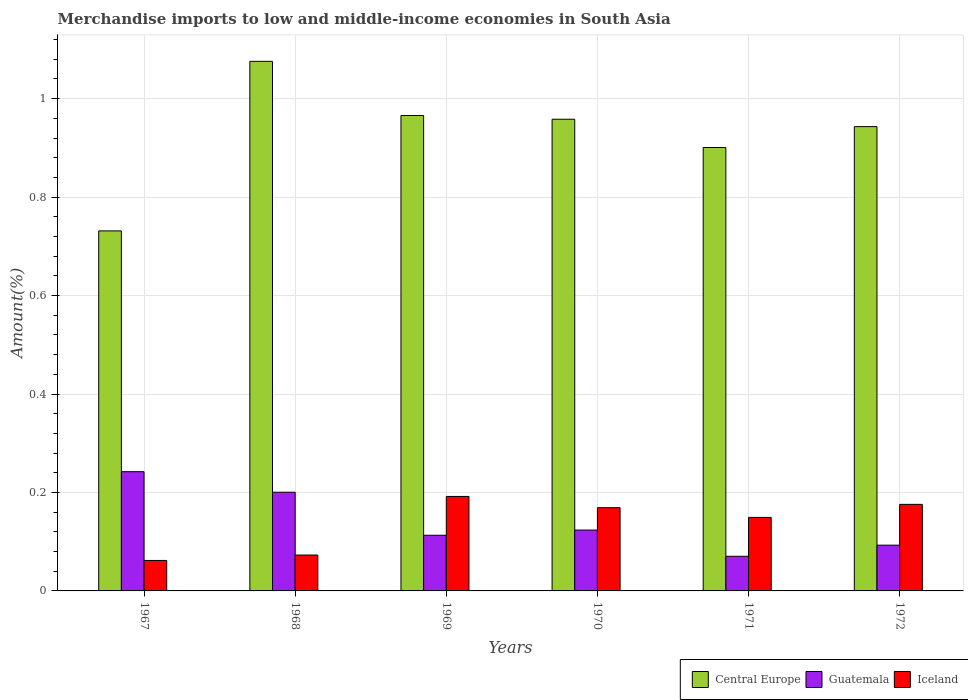How many different coloured bars are there?
Your answer should be compact. 3. Are the number of bars per tick equal to the number of legend labels?
Keep it short and to the point. Yes. Are the number of bars on each tick of the X-axis equal?
Offer a terse response. Yes. How many bars are there on the 4th tick from the left?
Your answer should be very brief. 3. What is the label of the 4th group of bars from the left?
Keep it short and to the point. 1970. In how many cases, is the number of bars for a given year not equal to the number of legend labels?
Offer a terse response. 0. What is the percentage of amount earned from merchandise imports in Central Europe in 1972?
Your response must be concise. 0.94. Across all years, what is the maximum percentage of amount earned from merchandise imports in Iceland?
Your answer should be compact. 0.19. Across all years, what is the minimum percentage of amount earned from merchandise imports in Guatemala?
Provide a succinct answer. 0.07. In which year was the percentage of amount earned from merchandise imports in Guatemala maximum?
Your answer should be very brief. 1967. In which year was the percentage of amount earned from merchandise imports in Central Europe minimum?
Keep it short and to the point. 1967. What is the total percentage of amount earned from merchandise imports in Guatemala in the graph?
Provide a succinct answer. 0.84. What is the difference between the percentage of amount earned from merchandise imports in Guatemala in 1968 and that in 1970?
Give a very brief answer. 0.08. What is the difference between the percentage of amount earned from merchandise imports in Guatemala in 1968 and the percentage of amount earned from merchandise imports in Central Europe in 1971?
Make the answer very short. -0.7. What is the average percentage of amount earned from merchandise imports in Iceland per year?
Provide a short and direct response. 0.14. In the year 1972, what is the difference between the percentage of amount earned from merchandise imports in Central Europe and percentage of amount earned from merchandise imports in Iceland?
Keep it short and to the point. 0.77. What is the ratio of the percentage of amount earned from merchandise imports in Iceland in 1967 to that in 1972?
Keep it short and to the point. 0.35. Is the difference between the percentage of amount earned from merchandise imports in Central Europe in 1967 and 1971 greater than the difference between the percentage of amount earned from merchandise imports in Iceland in 1967 and 1971?
Give a very brief answer. No. What is the difference between the highest and the second highest percentage of amount earned from merchandise imports in Central Europe?
Your response must be concise. 0.11. What is the difference between the highest and the lowest percentage of amount earned from merchandise imports in Central Europe?
Provide a short and direct response. 0.34. In how many years, is the percentage of amount earned from merchandise imports in Central Europe greater than the average percentage of amount earned from merchandise imports in Central Europe taken over all years?
Give a very brief answer. 4. Is the sum of the percentage of amount earned from merchandise imports in Central Europe in 1967 and 1972 greater than the maximum percentage of amount earned from merchandise imports in Iceland across all years?
Provide a short and direct response. Yes. What does the 2nd bar from the left in 1971 represents?
Provide a succinct answer. Guatemala. What does the 3rd bar from the right in 1971 represents?
Your response must be concise. Central Europe. How many bars are there?
Give a very brief answer. 18. Are all the bars in the graph horizontal?
Give a very brief answer. No. How many years are there in the graph?
Keep it short and to the point. 6. What is the difference between two consecutive major ticks on the Y-axis?
Your answer should be very brief. 0.2. Does the graph contain any zero values?
Provide a short and direct response. No. Where does the legend appear in the graph?
Provide a succinct answer. Bottom right. What is the title of the graph?
Ensure brevity in your answer.  Merchandise imports to low and middle-income economies in South Asia. What is the label or title of the Y-axis?
Offer a terse response. Amount(%). What is the Amount(%) in Central Europe in 1967?
Give a very brief answer. 0.73. What is the Amount(%) of Guatemala in 1967?
Provide a succinct answer. 0.24. What is the Amount(%) of Iceland in 1967?
Keep it short and to the point. 0.06. What is the Amount(%) in Central Europe in 1968?
Give a very brief answer. 1.08. What is the Amount(%) of Guatemala in 1968?
Provide a short and direct response. 0.2. What is the Amount(%) of Iceland in 1968?
Give a very brief answer. 0.07. What is the Amount(%) in Central Europe in 1969?
Make the answer very short. 0.97. What is the Amount(%) in Guatemala in 1969?
Your response must be concise. 0.11. What is the Amount(%) of Iceland in 1969?
Your answer should be very brief. 0.19. What is the Amount(%) in Central Europe in 1970?
Give a very brief answer. 0.96. What is the Amount(%) of Guatemala in 1970?
Provide a succinct answer. 0.12. What is the Amount(%) of Iceland in 1970?
Provide a short and direct response. 0.17. What is the Amount(%) of Central Europe in 1971?
Your response must be concise. 0.9. What is the Amount(%) of Guatemala in 1971?
Your response must be concise. 0.07. What is the Amount(%) of Iceland in 1971?
Ensure brevity in your answer.  0.15. What is the Amount(%) of Central Europe in 1972?
Provide a short and direct response. 0.94. What is the Amount(%) of Guatemala in 1972?
Offer a terse response. 0.09. What is the Amount(%) of Iceland in 1972?
Offer a terse response. 0.18. Across all years, what is the maximum Amount(%) in Central Europe?
Provide a short and direct response. 1.08. Across all years, what is the maximum Amount(%) in Guatemala?
Your answer should be very brief. 0.24. Across all years, what is the maximum Amount(%) in Iceland?
Ensure brevity in your answer.  0.19. Across all years, what is the minimum Amount(%) in Central Europe?
Your answer should be very brief. 0.73. Across all years, what is the minimum Amount(%) of Guatemala?
Provide a succinct answer. 0.07. Across all years, what is the minimum Amount(%) of Iceland?
Provide a short and direct response. 0.06. What is the total Amount(%) of Central Europe in the graph?
Ensure brevity in your answer.  5.58. What is the total Amount(%) of Guatemala in the graph?
Keep it short and to the point. 0.84. What is the total Amount(%) of Iceland in the graph?
Your answer should be compact. 0.82. What is the difference between the Amount(%) of Central Europe in 1967 and that in 1968?
Give a very brief answer. -0.34. What is the difference between the Amount(%) in Guatemala in 1967 and that in 1968?
Ensure brevity in your answer.  0.04. What is the difference between the Amount(%) of Iceland in 1967 and that in 1968?
Your response must be concise. -0.01. What is the difference between the Amount(%) of Central Europe in 1967 and that in 1969?
Provide a short and direct response. -0.23. What is the difference between the Amount(%) of Guatemala in 1967 and that in 1969?
Ensure brevity in your answer.  0.13. What is the difference between the Amount(%) in Iceland in 1967 and that in 1969?
Keep it short and to the point. -0.13. What is the difference between the Amount(%) of Central Europe in 1967 and that in 1970?
Provide a succinct answer. -0.23. What is the difference between the Amount(%) of Guatemala in 1967 and that in 1970?
Offer a very short reply. 0.12. What is the difference between the Amount(%) of Iceland in 1967 and that in 1970?
Make the answer very short. -0.11. What is the difference between the Amount(%) of Central Europe in 1967 and that in 1971?
Provide a short and direct response. -0.17. What is the difference between the Amount(%) of Guatemala in 1967 and that in 1971?
Offer a terse response. 0.17. What is the difference between the Amount(%) in Iceland in 1967 and that in 1971?
Make the answer very short. -0.09. What is the difference between the Amount(%) in Central Europe in 1967 and that in 1972?
Offer a terse response. -0.21. What is the difference between the Amount(%) in Guatemala in 1967 and that in 1972?
Provide a succinct answer. 0.15. What is the difference between the Amount(%) in Iceland in 1967 and that in 1972?
Provide a succinct answer. -0.11. What is the difference between the Amount(%) in Central Europe in 1968 and that in 1969?
Offer a terse response. 0.11. What is the difference between the Amount(%) in Guatemala in 1968 and that in 1969?
Offer a terse response. 0.09. What is the difference between the Amount(%) of Iceland in 1968 and that in 1969?
Your response must be concise. -0.12. What is the difference between the Amount(%) in Central Europe in 1968 and that in 1970?
Your answer should be very brief. 0.12. What is the difference between the Amount(%) of Guatemala in 1968 and that in 1970?
Provide a short and direct response. 0.08. What is the difference between the Amount(%) of Iceland in 1968 and that in 1970?
Offer a very short reply. -0.1. What is the difference between the Amount(%) in Central Europe in 1968 and that in 1971?
Offer a terse response. 0.17. What is the difference between the Amount(%) in Guatemala in 1968 and that in 1971?
Offer a very short reply. 0.13. What is the difference between the Amount(%) of Iceland in 1968 and that in 1971?
Your answer should be compact. -0.08. What is the difference between the Amount(%) of Central Europe in 1968 and that in 1972?
Your response must be concise. 0.13. What is the difference between the Amount(%) in Guatemala in 1968 and that in 1972?
Offer a terse response. 0.11. What is the difference between the Amount(%) of Iceland in 1968 and that in 1972?
Your response must be concise. -0.1. What is the difference between the Amount(%) in Central Europe in 1969 and that in 1970?
Make the answer very short. 0.01. What is the difference between the Amount(%) of Guatemala in 1969 and that in 1970?
Your answer should be very brief. -0.01. What is the difference between the Amount(%) in Iceland in 1969 and that in 1970?
Offer a very short reply. 0.02. What is the difference between the Amount(%) of Central Europe in 1969 and that in 1971?
Provide a short and direct response. 0.07. What is the difference between the Amount(%) in Guatemala in 1969 and that in 1971?
Keep it short and to the point. 0.04. What is the difference between the Amount(%) in Iceland in 1969 and that in 1971?
Ensure brevity in your answer.  0.04. What is the difference between the Amount(%) in Central Europe in 1969 and that in 1972?
Your response must be concise. 0.02. What is the difference between the Amount(%) of Guatemala in 1969 and that in 1972?
Give a very brief answer. 0.02. What is the difference between the Amount(%) in Iceland in 1969 and that in 1972?
Offer a terse response. 0.02. What is the difference between the Amount(%) of Central Europe in 1970 and that in 1971?
Ensure brevity in your answer.  0.06. What is the difference between the Amount(%) in Guatemala in 1970 and that in 1971?
Keep it short and to the point. 0.05. What is the difference between the Amount(%) in Iceland in 1970 and that in 1971?
Your response must be concise. 0.02. What is the difference between the Amount(%) in Central Europe in 1970 and that in 1972?
Keep it short and to the point. 0.01. What is the difference between the Amount(%) of Guatemala in 1970 and that in 1972?
Offer a terse response. 0.03. What is the difference between the Amount(%) of Iceland in 1970 and that in 1972?
Give a very brief answer. -0.01. What is the difference between the Amount(%) in Central Europe in 1971 and that in 1972?
Your answer should be compact. -0.04. What is the difference between the Amount(%) in Guatemala in 1971 and that in 1972?
Ensure brevity in your answer.  -0.02. What is the difference between the Amount(%) in Iceland in 1971 and that in 1972?
Make the answer very short. -0.03. What is the difference between the Amount(%) in Central Europe in 1967 and the Amount(%) in Guatemala in 1968?
Your response must be concise. 0.53. What is the difference between the Amount(%) in Central Europe in 1967 and the Amount(%) in Iceland in 1968?
Provide a short and direct response. 0.66. What is the difference between the Amount(%) in Guatemala in 1967 and the Amount(%) in Iceland in 1968?
Ensure brevity in your answer.  0.17. What is the difference between the Amount(%) of Central Europe in 1967 and the Amount(%) of Guatemala in 1969?
Provide a short and direct response. 0.62. What is the difference between the Amount(%) in Central Europe in 1967 and the Amount(%) in Iceland in 1969?
Your answer should be very brief. 0.54. What is the difference between the Amount(%) in Guatemala in 1967 and the Amount(%) in Iceland in 1969?
Your response must be concise. 0.05. What is the difference between the Amount(%) of Central Europe in 1967 and the Amount(%) of Guatemala in 1970?
Offer a terse response. 0.61. What is the difference between the Amount(%) of Central Europe in 1967 and the Amount(%) of Iceland in 1970?
Keep it short and to the point. 0.56. What is the difference between the Amount(%) of Guatemala in 1967 and the Amount(%) of Iceland in 1970?
Your response must be concise. 0.07. What is the difference between the Amount(%) in Central Europe in 1967 and the Amount(%) in Guatemala in 1971?
Offer a terse response. 0.66. What is the difference between the Amount(%) of Central Europe in 1967 and the Amount(%) of Iceland in 1971?
Provide a short and direct response. 0.58. What is the difference between the Amount(%) in Guatemala in 1967 and the Amount(%) in Iceland in 1971?
Offer a very short reply. 0.09. What is the difference between the Amount(%) in Central Europe in 1967 and the Amount(%) in Guatemala in 1972?
Your answer should be compact. 0.64. What is the difference between the Amount(%) of Central Europe in 1967 and the Amount(%) of Iceland in 1972?
Keep it short and to the point. 0.56. What is the difference between the Amount(%) of Guatemala in 1967 and the Amount(%) of Iceland in 1972?
Offer a terse response. 0.07. What is the difference between the Amount(%) of Central Europe in 1968 and the Amount(%) of Guatemala in 1969?
Provide a succinct answer. 0.96. What is the difference between the Amount(%) in Central Europe in 1968 and the Amount(%) in Iceland in 1969?
Provide a short and direct response. 0.88. What is the difference between the Amount(%) of Guatemala in 1968 and the Amount(%) of Iceland in 1969?
Your answer should be compact. 0.01. What is the difference between the Amount(%) in Central Europe in 1968 and the Amount(%) in Guatemala in 1970?
Your answer should be compact. 0.95. What is the difference between the Amount(%) of Central Europe in 1968 and the Amount(%) of Iceland in 1970?
Provide a succinct answer. 0.91. What is the difference between the Amount(%) in Guatemala in 1968 and the Amount(%) in Iceland in 1970?
Your response must be concise. 0.03. What is the difference between the Amount(%) in Central Europe in 1968 and the Amount(%) in Guatemala in 1971?
Provide a succinct answer. 1.01. What is the difference between the Amount(%) in Central Europe in 1968 and the Amount(%) in Iceland in 1971?
Your response must be concise. 0.93. What is the difference between the Amount(%) in Guatemala in 1968 and the Amount(%) in Iceland in 1971?
Keep it short and to the point. 0.05. What is the difference between the Amount(%) in Central Europe in 1968 and the Amount(%) in Guatemala in 1972?
Provide a succinct answer. 0.98. What is the difference between the Amount(%) of Central Europe in 1968 and the Amount(%) of Iceland in 1972?
Your answer should be very brief. 0.9. What is the difference between the Amount(%) in Guatemala in 1968 and the Amount(%) in Iceland in 1972?
Provide a succinct answer. 0.02. What is the difference between the Amount(%) of Central Europe in 1969 and the Amount(%) of Guatemala in 1970?
Offer a terse response. 0.84. What is the difference between the Amount(%) of Central Europe in 1969 and the Amount(%) of Iceland in 1970?
Keep it short and to the point. 0.8. What is the difference between the Amount(%) of Guatemala in 1969 and the Amount(%) of Iceland in 1970?
Your response must be concise. -0.06. What is the difference between the Amount(%) in Central Europe in 1969 and the Amount(%) in Guatemala in 1971?
Make the answer very short. 0.9. What is the difference between the Amount(%) of Central Europe in 1969 and the Amount(%) of Iceland in 1971?
Offer a very short reply. 0.82. What is the difference between the Amount(%) of Guatemala in 1969 and the Amount(%) of Iceland in 1971?
Your answer should be very brief. -0.04. What is the difference between the Amount(%) of Central Europe in 1969 and the Amount(%) of Guatemala in 1972?
Ensure brevity in your answer.  0.87. What is the difference between the Amount(%) of Central Europe in 1969 and the Amount(%) of Iceland in 1972?
Your answer should be very brief. 0.79. What is the difference between the Amount(%) in Guatemala in 1969 and the Amount(%) in Iceland in 1972?
Your answer should be very brief. -0.06. What is the difference between the Amount(%) in Central Europe in 1970 and the Amount(%) in Guatemala in 1971?
Provide a succinct answer. 0.89. What is the difference between the Amount(%) of Central Europe in 1970 and the Amount(%) of Iceland in 1971?
Your answer should be compact. 0.81. What is the difference between the Amount(%) of Guatemala in 1970 and the Amount(%) of Iceland in 1971?
Offer a very short reply. -0.03. What is the difference between the Amount(%) in Central Europe in 1970 and the Amount(%) in Guatemala in 1972?
Provide a short and direct response. 0.87. What is the difference between the Amount(%) of Central Europe in 1970 and the Amount(%) of Iceland in 1972?
Keep it short and to the point. 0.78. What is the difference between the Amount(%) in Guatemala in 1970 and the Amount(%) in Iceland in 1972?
Your answer should be compact. -0.05. What is the difference between the Amount(%) of Central Europe in 1971 and the Amount(%) of Guatemala in 1972?
Your response must be concise. 0.81. What is the difference between the Amount(%) of Central Europe in 1971 and the Amount(%) of Iceland in 1972?
Ensure brevity in your answer.  0.72. What is the difference between the Amount(%) in Guatemala in 1971 and the Amount(%) in Iceland in 1972?
Keep it short and to the point. -0.11. What is the average Amount(%) of Central Europe per year?
Offer a terse response. 0.93. What is the average Amount(%) of Guatemala per year?
Provide a succinct answer. 0.14. What is the average Amount(%) of Iceland per year?
Offer a terse response. 0.14. In the year 1967, what is the difference between the Amount(%) of Central Europe and Amount(%) of Guatemala?
Your answer should be very brief. 0.49. In the year 1967, what is the difference between the Amount(%) of Central Europe and Amount(%) of Iceland?
Offer a terse response. 0.67. In the year 1967, what is the difference between the Amount(%) in Guatemala and Amount(%) in Iceland?
Provide a succinct answer. 0.18. In the year 1968, what is the difference between the Amount(%) in Central Europe and Amount(%) in Guatemala?
Your response must be concise. 0.88. In the year 1968, what is the difference between the Amount(%) of Central Europe and Amount(%) of Iceland?
Offer a very short reply. 1. In the year 1968, what is the difference between the Amount(%) in Guatemala and Amount(%) in Iceland?
Your response must be concise. 0.13. In the year 1969, what is the difference between the Amount(%) in Central Europe and Amount(%) in Guatemala?
Offer a very short reply. 0.85. In the year 1969, what is the difference between the Amount(%) of Central Europe and Amount(%) of Iceland?
Ensure brevity in your answer.  0.77. In the year 1969, what is the difference between the Amount(%) in Guatemala and Amount(%) in Iceland?
Provide a succinct answer. -0.08. In the year 1970, what is the difference between the Amount(%) of Central Europe and Amount(%) of Guatemala?
Keep it short and to the point. 0.83. In the year 1970, what is the difference between the Amount(%) in Central Europe and Amount(%) in Iceland?
Give a very brief answer. 0.79. In the year 1970, what is the difference between the Amount(%) of Guatemala and Amount(%) of Iceland?
Your answer should be compact. -0.05. In the year 1971, what is the difference between the Amount(%) of Central Europe and Amount(%) of Guatemala?
Ensure brevity in your answer.  0.83. In the year 1971, what is the difference between the Amount(%) of Central Europe and Amount(%) of Iceland?
Ensure brevity in your answer.  0.75. In the year 1971, what is the difference between the Amount(%) in Guatemala and Amount(%) in Iceland?
Offer a very short reply. -0.08. In the year 1972, what is the difference between the Amount(%) of Central Europe and Amount(%) of Guatemala?
Give a very brief answer. 0.85. In the year 1972, what is the difference between the Amount(%) in Central Europe and Amount(%) in Iceland?
Your answer should be very brief. 0.77. In the year 1972, what is the difference between the Amount(%) of Guatemala and Amount(%) of Iceland?
Your answer should be compact. -0.08. What is the ratio of the Amount(%) of Central Europe in 1967 to that in 1968?
Your response must be concise. 0.68. What is the ratio of the Amount(%) in Guatemala in 1967 to that in 1968?
Keep it short and to the point. 1.21. What is the ratio of the Amount(%) in Iceland in 1967 to that in 1968?
Make the answer very short. 0.85. What is the ratio of the Amount(%) in Central Europe in 1967 to that in 1969?
Make the answer very short. 0.76. What is the ratio of the Amount(%) of Guatemala in 1967 to that in 1969?
Keep it short and to the point. 2.14. What is the ratio of the Amount(%) in Iceland in 1967 to that in 1969?
Keep it short and to the point. 0.32. What is the ratio of the Amount(%) of Central Europe in 1967 to that in 1970?
Offer a very short reply. 0.76. What is the ratio of the Amount(%) of Guatemala in 1967 to that in 1970?
Your answer should be very brief. 1.96. What is the ratio of the Amount(%) in Iceland in 1967 to that in 1970?
Offer a terse response. 0.37. What is the ratio of the Amount(%) of Central Europe in 1967 to that in 1971?
Your answer should be compact. 0.81. What is the ratio of the Amount(%) in Guatemala in 1967 to that in 1971?
Your answer should be compact. 3.44. What is the ratio of the Amount(%) of Iceland in 1967 to that in 1971?
Make the answer very short. 0.41. What is the ratio of the Amount(%) in Central Europe in 1967 to that in 1972?
Provide a succinct answer. 0.78. What is the ratio of the Amount(%) of Guatemala in 1967 to that in 1972?
Your answer should be compact. 2.61. What is the ratio of the Amount(%) of Iceland in 1967 to that in 1972?
Give a very brief answer. 0.35. What is the ratio of the Amount(%) of Central Europe in 1968 to that in 1969?
Your answer should be very brief. 1.11. What is the ratio of the Amount(%) in Guatemala in 1968 to that in 1969?
Provide a succinct answer. 1.77. What is the ratio of the Amount(%) of Iceland in 1968 to that in 1969?
Offer a terse response. 0.38. What is the ratio of the Amount(%) in Central Europe in 1968 to that in 1970?
Offer a terse response. 1.12. What is the ratio of the Amount(%) of Guatemala in 1968 to that in 1970?
Your answer should be compact. 1.62. What is the ratio of the Amount(%) of Iceland in 1968 to that in 1970?
Ensure brevity in your answer.  0.43. What is the ratio of the Amount(%) in Central Europe in 1968 to that in 1971?
Give a very brief answer. 1.19. What is the ratio of the Amount(%) in Guatemala in 1968 to that in 1971?
Your response must be concise. 2.85. What is the ratio of the Amount(%) of Iceland in 1968 to that in 1971?
Make the answer very short. 0.49. What is the ratio of the Amount(%) of Central Europe in 1968 to that in 1972?
Offer a very short reply. 1.14. What is the ratio of the Amount(%) in Guatemala in 1968 to that in 1972?
Provide a short and direct response. 2.16. What is the ratio of the Amount(%) of Iceland in 1968 to that in 1972?
Your response must be concise. 0.41. What is the ratio of the Amount(%) of Central Europe in 1969 to that in 1970?
Ensure brevity in your answer.  1.01. What is the ratio of the Amount(%) in Guatemala in 1969 to that in 1970?
Your response must be concise. 0.91. What is the ratio of the Amount(%) of Iceland in 1969 to that in 1970?
Ensure brevity in your answer.  1.14. What is the ratio of the Amount(%) of Central Europe in 1969 to that in 1971?
Provide a succinct answer. 1.07. What is the ratio of the Amount(%) of Guatemala in 1969 to that in 1971?
Keep it short and to the point. 1.61. What is the ratio of the Amount(%) in Iceland in 1969 to that in 1971?
Your answer should be compact. 1.29. What is the ratio of the Amount(%) in Central Europe in 1969 to that in 1972?
Ensure brevity in your answer.  1.02. What is the ratio of the Amount(%) in Guatemala in 1969 to that in 1972?
Offer a terse response. 1.22. What is the ratio of the Amount(%) of Iceland in 1969 to that in 1972?
Your response must be concise. 1.09. What is the ratio of the Amount(%) in Central Europe in 1970 to that in 1971?
Provide a short and direct response. 1.06. What is the ratio of the Amount(%) in Guatemala in 1970 to that in 1971?
Offer a very short reply. 1.76. What is the ratio of the Amount(%) in Iceland in 1970 to that in 1971?
Keep it short and to the point. 1.13. What is the ratio of the Amount(%) of Central Europe in 1970 to that in 1972?
Provide a short and direct response. 1.02. What is the ratio of the Amount(%) of Guatemala in 1970 to that in 1972?
Ensure brevity in your answer.  1.33. What is the ratio of the Amount(%) of Iceland in 1970 to that in 1972?
Keep it short and to the point. 0.96. What is the ratio of the Amount(%) in Central Europe in 1971 to that in 1972?
Offer a very short reply. 0.95. What is the ratio of the Amount(%) of Guatemala in 1971 to that in 1972?
Ensure brevity in your answer.  0.76. What is the ratio of the Amount(%) in Iceland in 1971 to that in 1972?
Make the answer very short. 0.85. What is the difference between the highest and the second highest Amount(%) in Central Europe?
Ensure brevity in your answer.  0.11. What is the difference between the highest and the second highest Amount(%) in Guatemala?
Keep it short and to the point. 0.04. What is the difference between the highest and the second highest Amount(%) in Iceland?
Keep it short and to the point. 0.02. What is the difference between the highest and the lowest Amount(%) of Central Europe?
Provide a short and direct response. 0.34. What is the difference between the highest and the lowest Amount(%) in Guatemala?
Provide a succinct answer. 0.17. What is the difference between the highest and the lowest Amount(%) of Iceland?
Your answer should be compact. 0.13. 